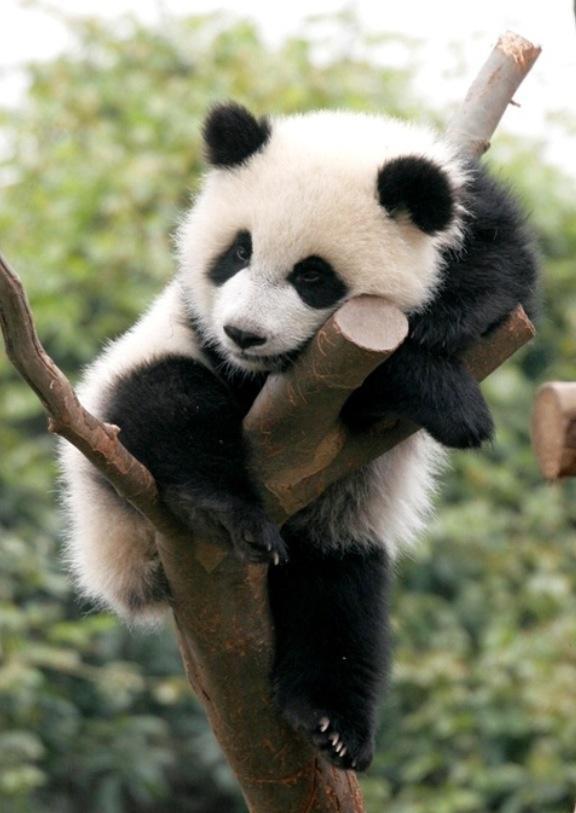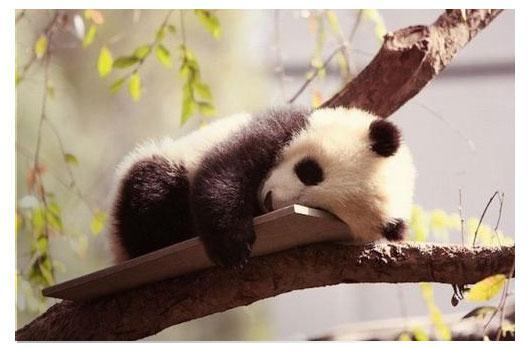The first image is the image on the left, the second image is the image on the right. Evaluate the accuracy of this statement regarding the images: "There are three pandas in total.". Is it true? Answer yes or no. No. The first image is the image on the left, the second image is the image on the right. Examine the images to the left and right. Is the description "Images show a total of two panda bears relaxing in the branches of leafless trees." accurate? Answer yes or no. Yes. 